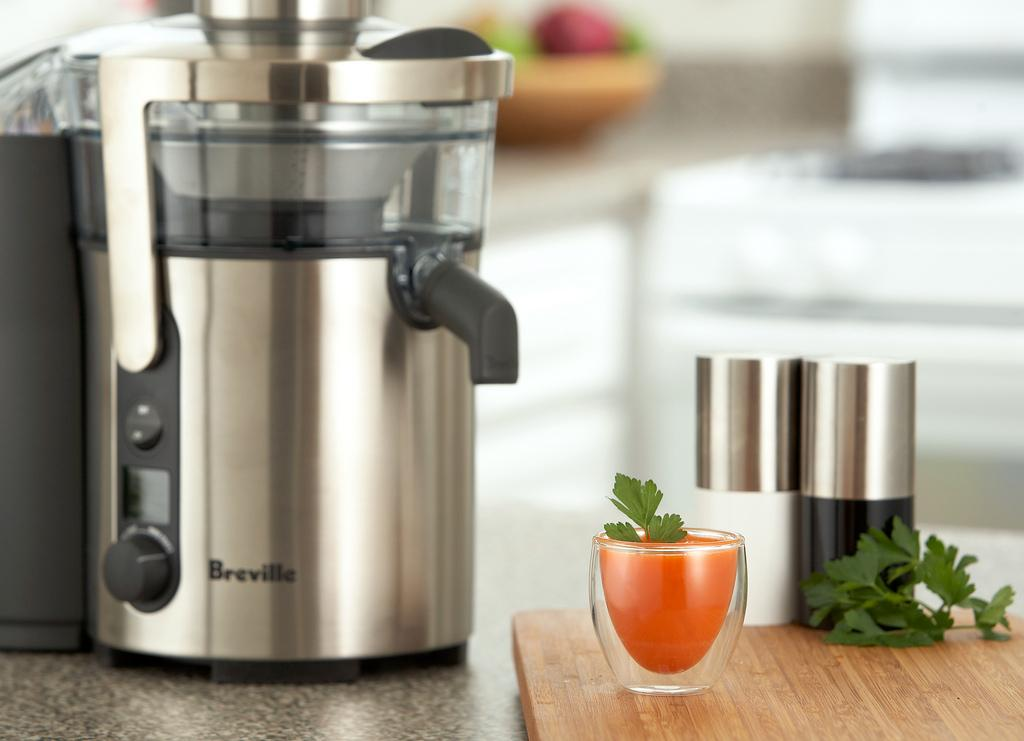Provide a one-sentence caption for the provided image. A Breville juicer with juice next to the product. 